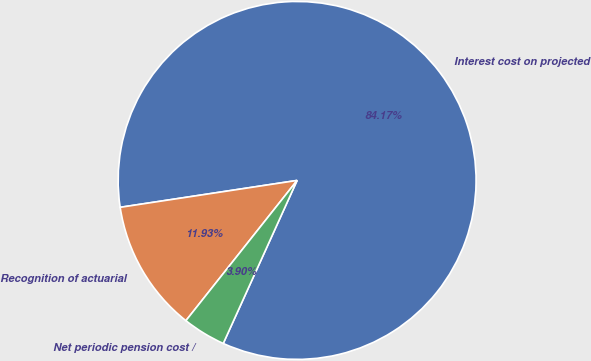Convert chart to OTSL. <chart><loc_0><loc_0><loc_500><loc_500><pie_chart><fcel>Interest cost on projected<fcel>Recognition of actuarial<fcel>Net periodic pension cost /<nl><fcel>84.18%<fcel>11.93%<fcel>3.9%<nl></chart> 